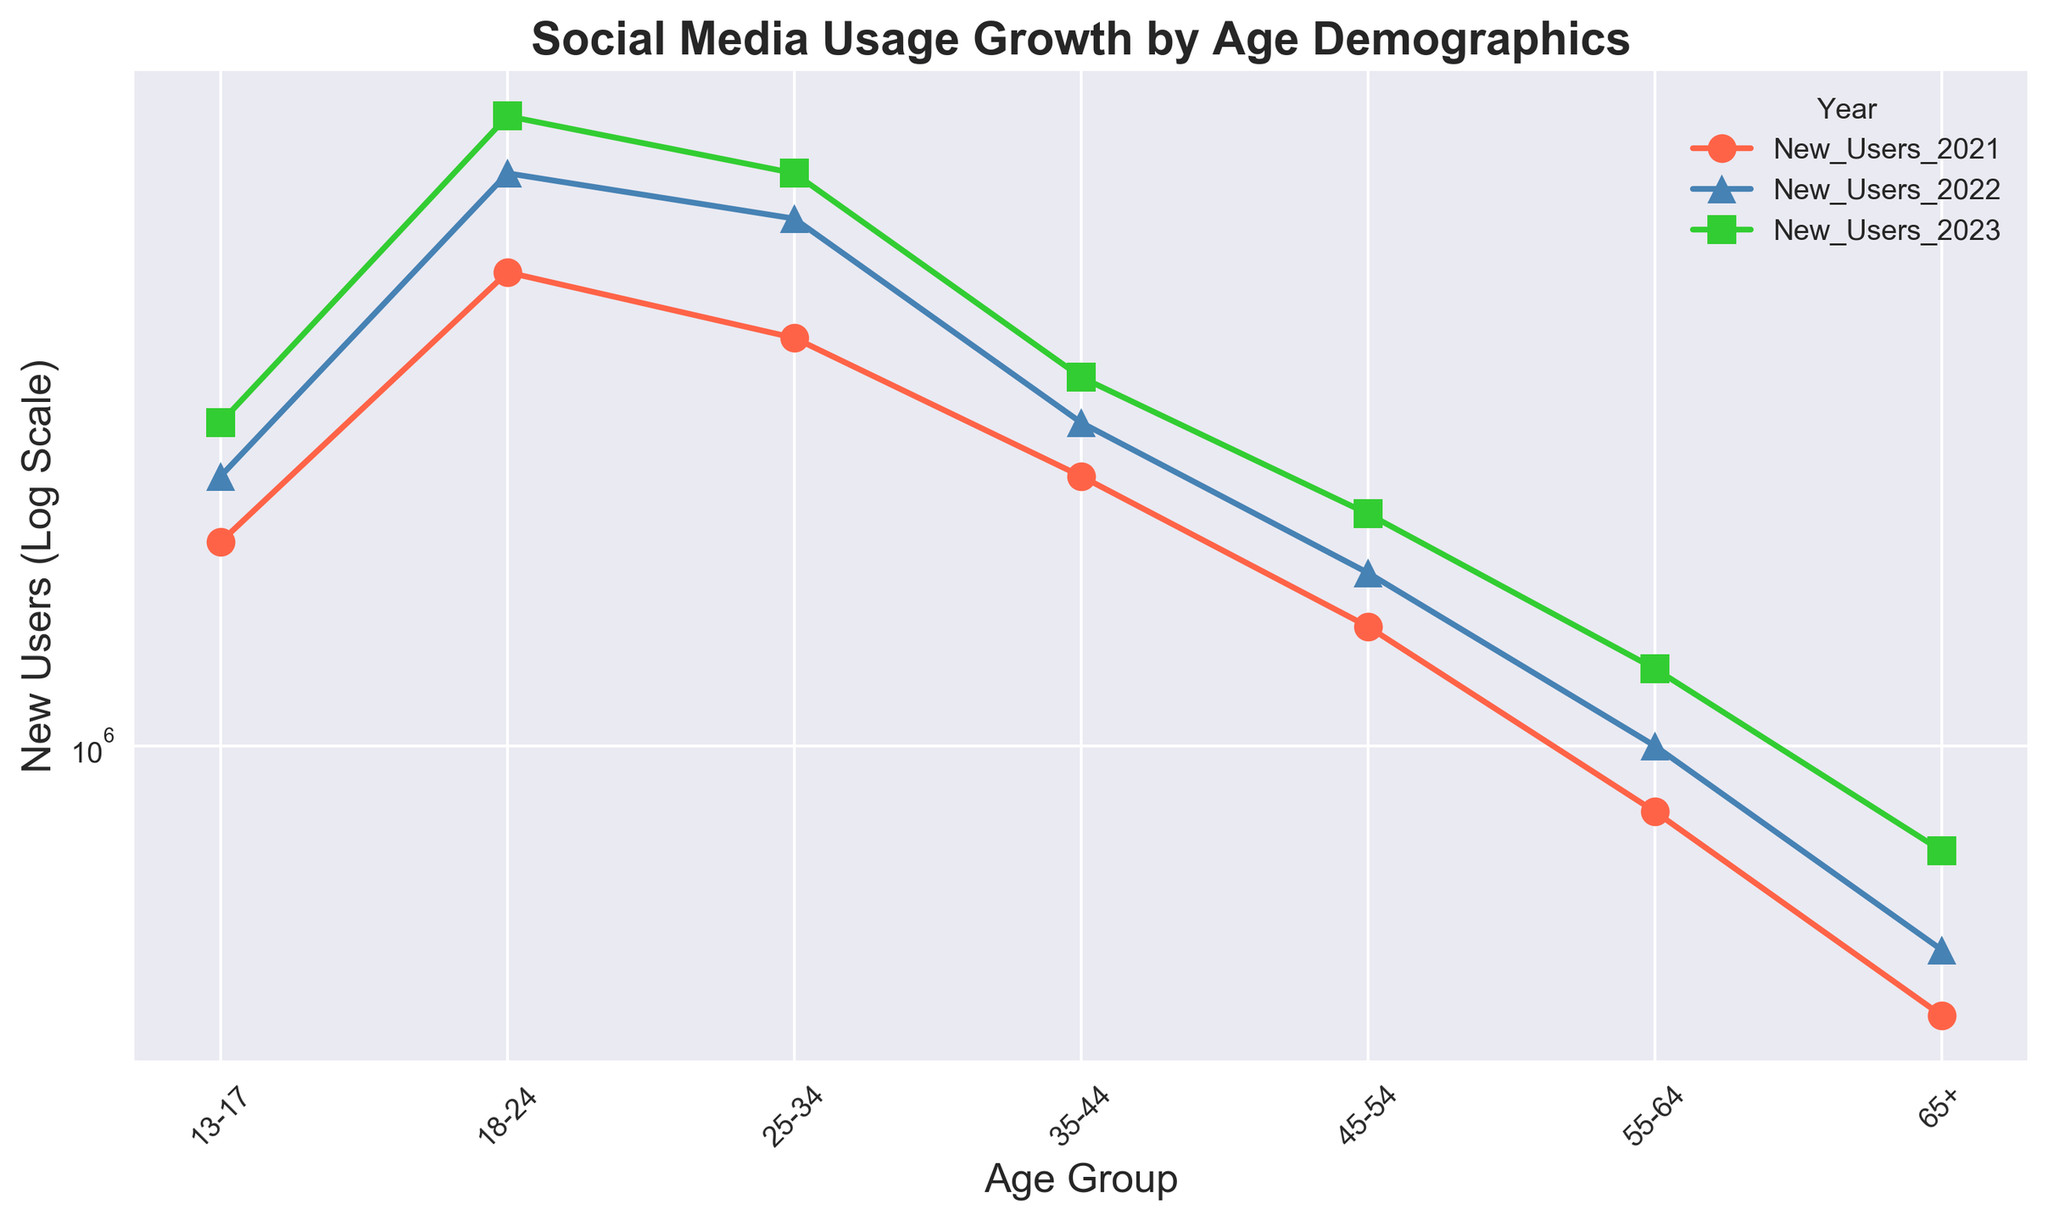Which age group had the highest number of new users in 2023? By examining the chart, locate the highest data point for the year 2023, which is indicated by the symbol for that year. The age group with the highest data point is 18-24.
Answer: 18-24 Which age group saw the smallest increase in new users from 2021 to 2023? Calculate the difference in new users from 2021 to 2023 for each age group. The smallest increase is observed in the 65+ age group (700,000 - 400,000 = 300,000).
Answer: 65+ Compare the number of new users in 2021 between the 35-44 and the 45-54 age groups. Which group has more? Locate the data points for 2021 for the 35-44 and the 45-54 age groups. The 35-44 age group has 2,500,000 new users, and the 45-54 age group has 1,500,000 new users. Hence, 35-44 has more.
Answer: 35-44 What is the sum of new users in 2023 for the 18-24 and the 25-34 age groups? Add the new users in 2023 for the 18-24 age group (8,500,000) and the 25-34 age group (7,000,000). The result is 8,500,000 + 7,000,000 = 15,500,000.
Answer: 15,500,000 Which year shows the most significant increase in new users for the 55-64 age group? Compare the differences in new users between each consecutive year for the 55-64 age group. For 2021 to 2022, the increase is 1,000,000 - 800,000 = 200,000. For 2022 to 2023, the increase is 1,300,000 - 1,000,000 = 300,000. The largest increase is observed between 2022 and 2023.
Answer: 2022 to 2023 Which year had the most number of new users for the 13-17 age group, and how many were there? Locate the highest data point for the 13-17 age group across the three years. The highest is in 2023 with 3,000,000 new users.
Answer: 2023, 3,000,000 How does the growth rate from 2021 to 2023 for the 25-34 age group compare to the 45-54 age group? Calculate the growth rate for each group: For 25-34, it's (7,000,000 - 4,000,000) / 4,000,000 = 0.75 (75% increase). For 45-54, it's (2,200,000 - 1,500,000) / 1,500,000 = 0.4667 (approximately 47% increase). The 25-34 age group has a higher growth rate.
Answer: 25-34 has a higher growth rate 